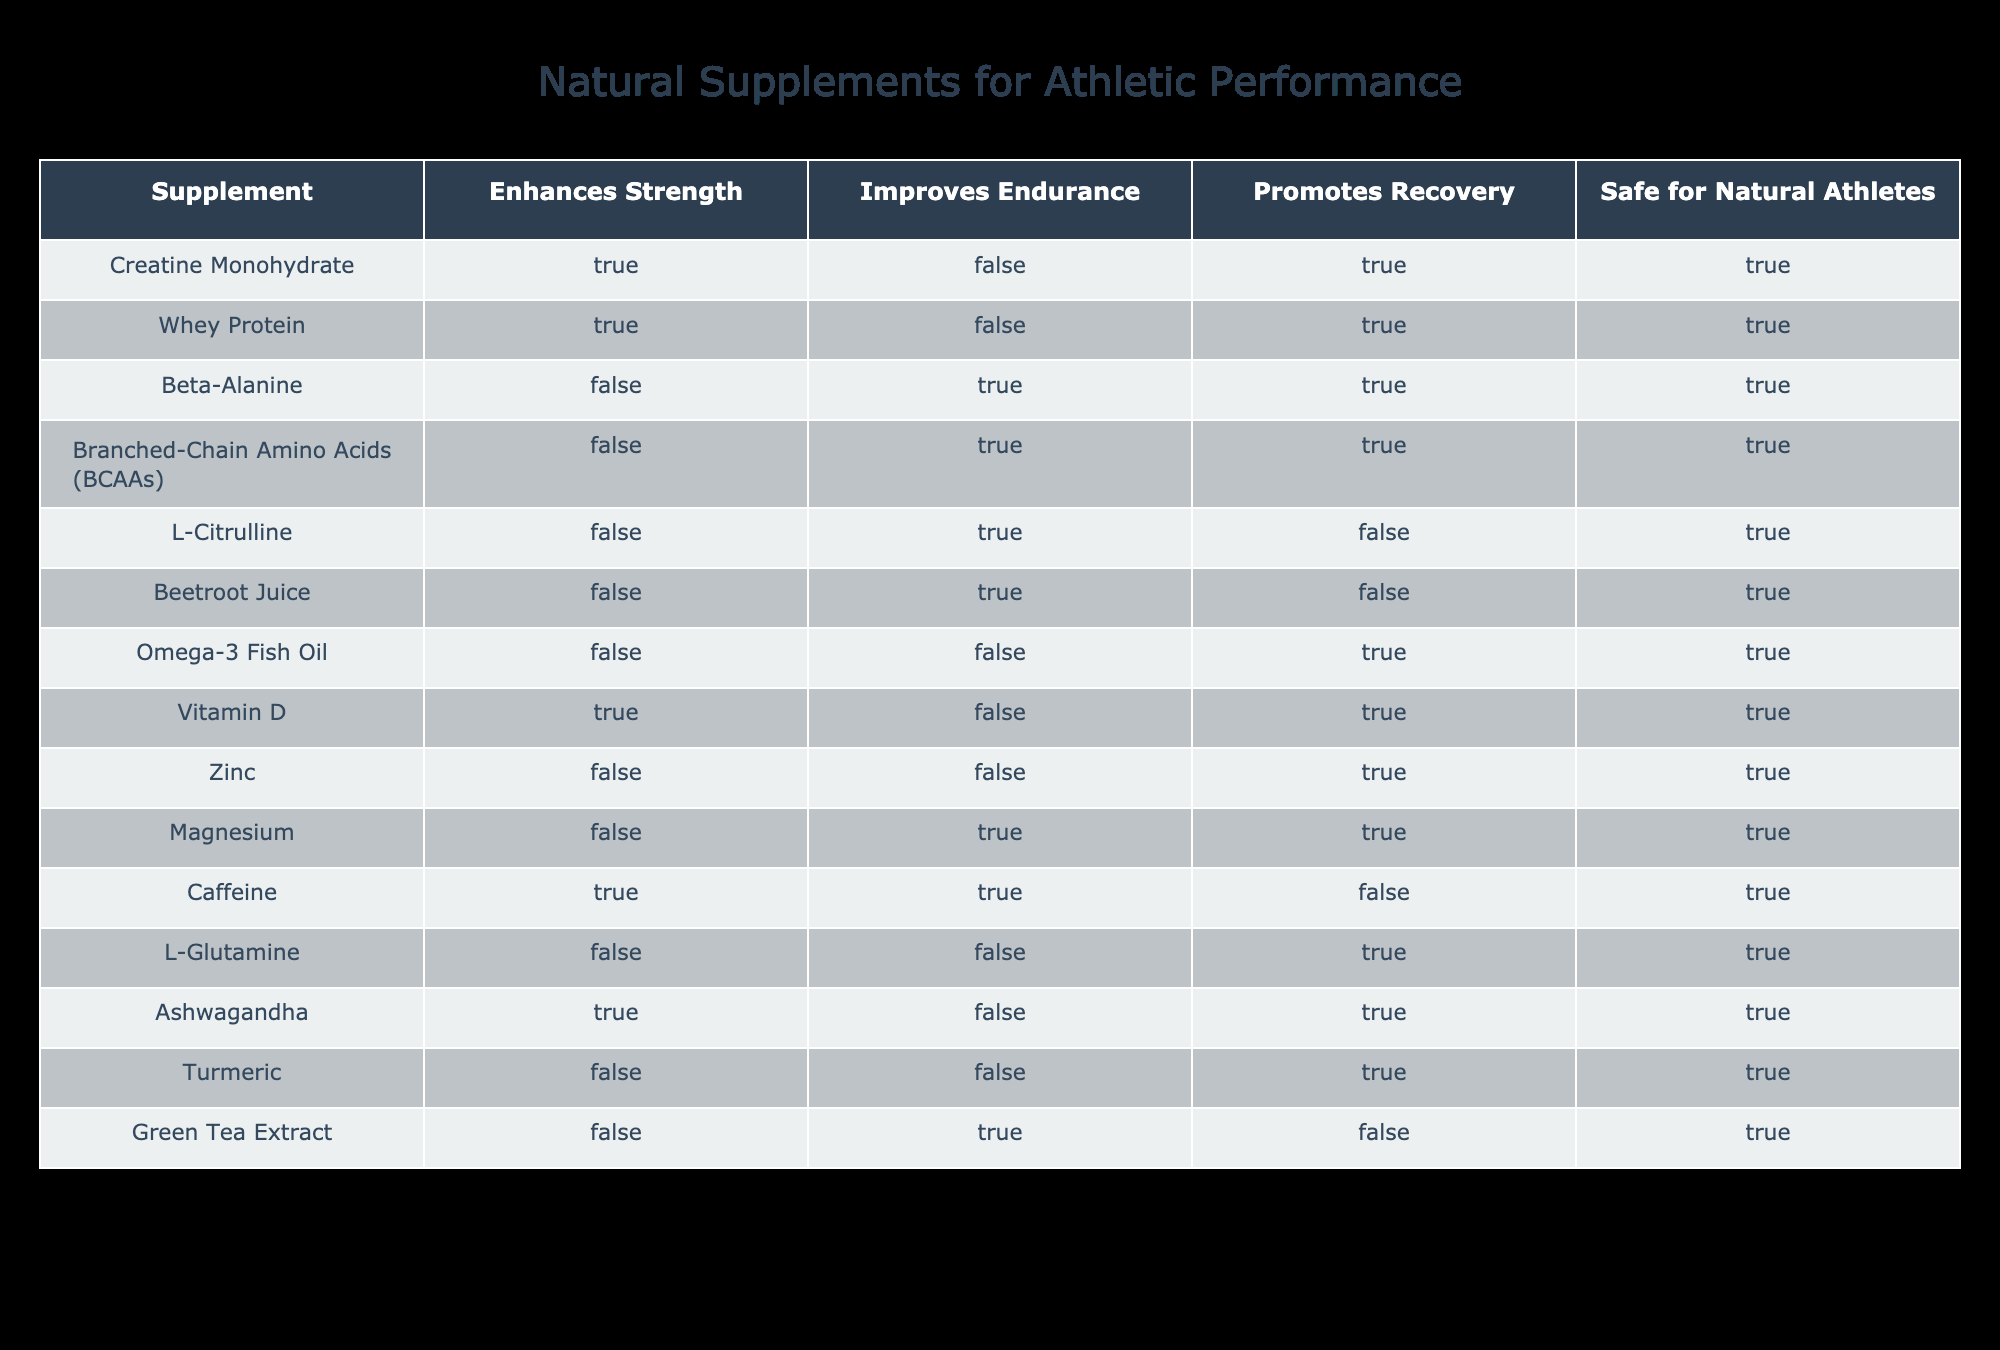What supplements enhance strength? By looking at the "Enhances Strength" column, we see that both Creatine Monohydrate, Whey Protein, Vitamin D, Caffeine, and Ashwagandha are marked as TRUE. Therefore, these supplements enhance strength.
Answer: Creatine Monohydrate, Whey Protein, Vitamin D, Caffeine, Ashwagandha How many supplements promote recovery? In the "Promotes Recovery" column, we count the TRUE values. The supplements that promote recovery are Creatine Monohydrate, Whey Protein, Beta-Alanine, Branched-Chain Amino Acids, Omega-3 Fish Oil, Zinc, Magnesium, L-Glutamine, Turmeric, and Ashwagandha. This gives us a total of 10 supplements.
Answer: 10 Is L-Citrulline safe for natural athletes? In the "Safe for Natural Athletes" column for L-Citrulline, the value is TRUE. This indicates that L-Citrulline is considered safe for natural athletes.
Answer: Yes Which supplement improves endurance but does not enhance strength? We look at the supplements where "Improves Endurance" is TRUE and "Enhances Strength" is FALSE. These are Beta-Alanine, Branched-Chain Amino Acids, and L-Citrulline.
Answer: Beta-Alanine, Branched-Chain Amino Acids, L-Citrulline What is the proportion of supplements that are safe for natural athletes and enhance strength? To find it, we first identify the supplements that enhance strength: Creatine Monohydrate, Whey Protein, Vitamin D, Caffeine, and Ashwagandha – 5 supplements. All of these supplements are also marked as safe for natural athletes. Therefore, the proportion is 5 out of 5 or 100%.
Answer: 100% Which supplement is the only one that enhances endurance and does not promote recovery? By reviewing the table, we see that L-Citrulline is indicated as improving endurance (TRUE) but not promoting recovery (FALSE). Therefore, L-Citrulline fits this criterion.
Answer: L-Citrulline Do any of the supplements enhance both strength and endurance? Checking the "Enhances Strength" and "Improves Endurance" columns, we find that Caffeine has both TRUE values in these columns, meaning it enhances both strength and endurance.
Answer: Yes How many supplements are indicated as safe for natural athletes and improve endurance? We count the TRUE values in the "Safe for Natural Athletes" column while also looking for TRUE values in the "Improves Endurance" column. These supplements are Beta-Alanine, Branched-Chain Amino Acids, L-Citrulline, and Magnesium which gives us 4 supplements.
Answer: 4 